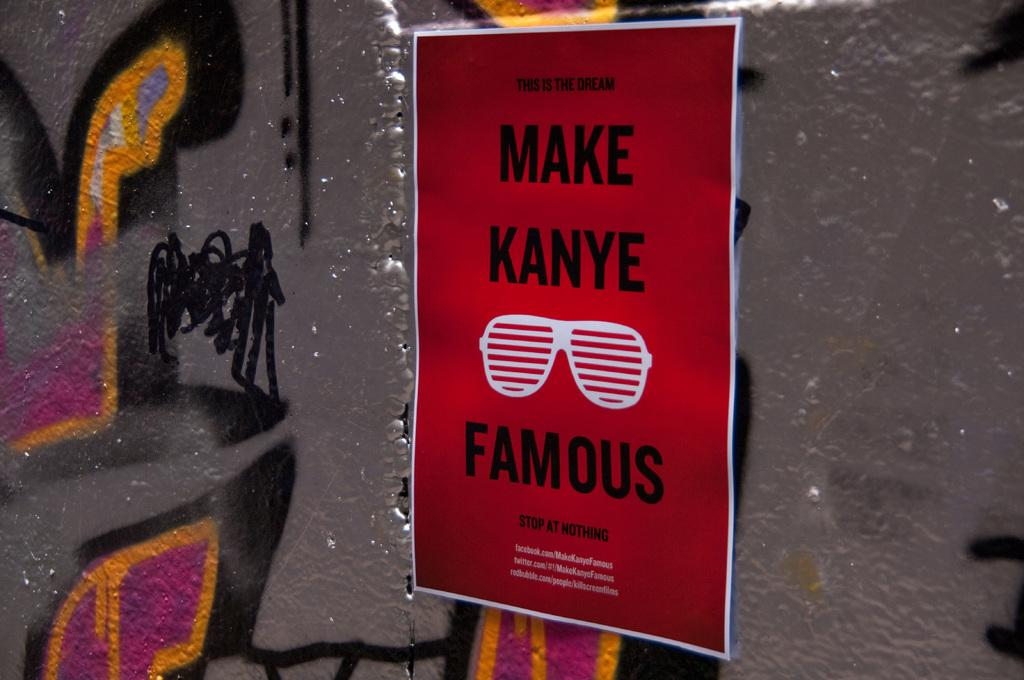<image>
Give a short and clear explanation of the subsequent image. A poster that says "make Kanye famous" shows a pair of white sunglasses. 